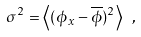<formula> <loc_0><loc_0><loc_500><loc_500>\sigma ^ { 2 } = \left \langle ( \phi _ { x } - \overline { \phi } ) ^ { 2 } \right \rangle \ ,</formula> 